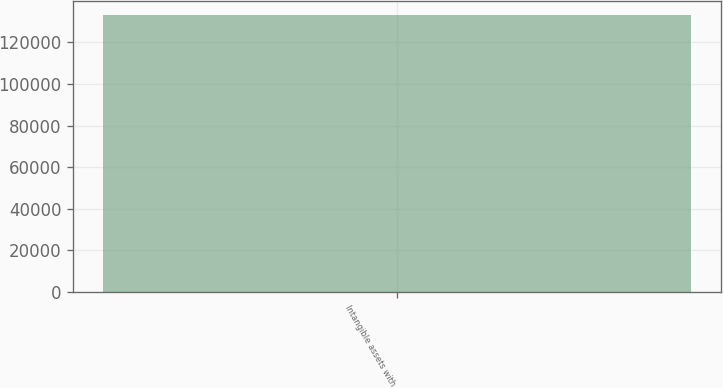<chart> <loc_0><loc_0><loc_500><loc_500><bar_chart><fcel>Intangible assets with<nl><fcel>133003<nl></chart> 